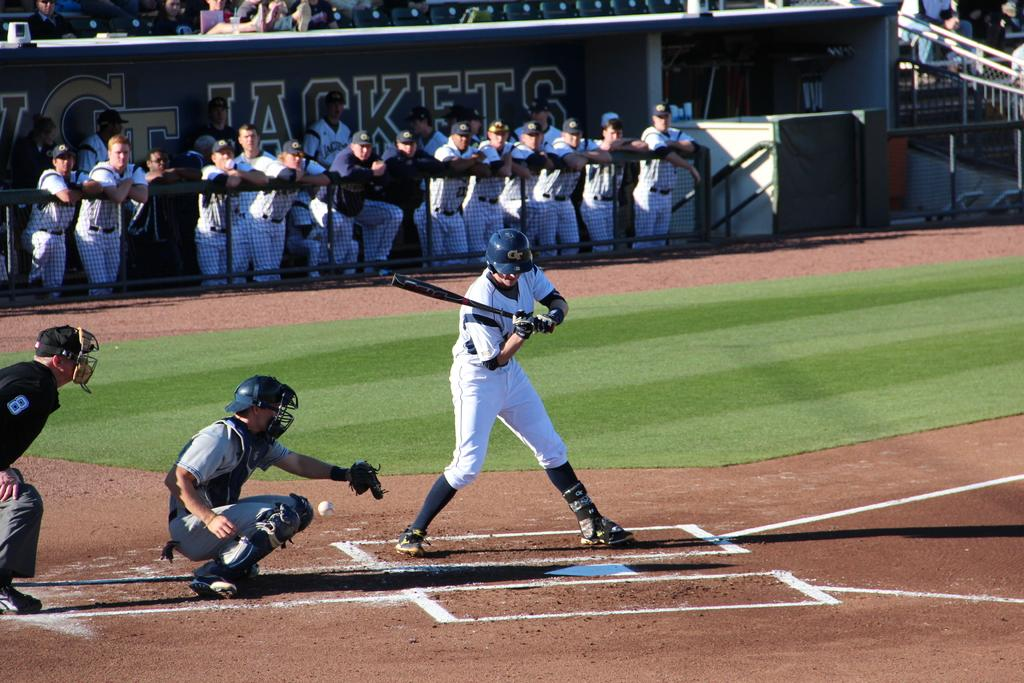<image>
Give a short and clear explanation of the subsequent image. Some baseball players; the word Jackets is visible on an advertising banner. 